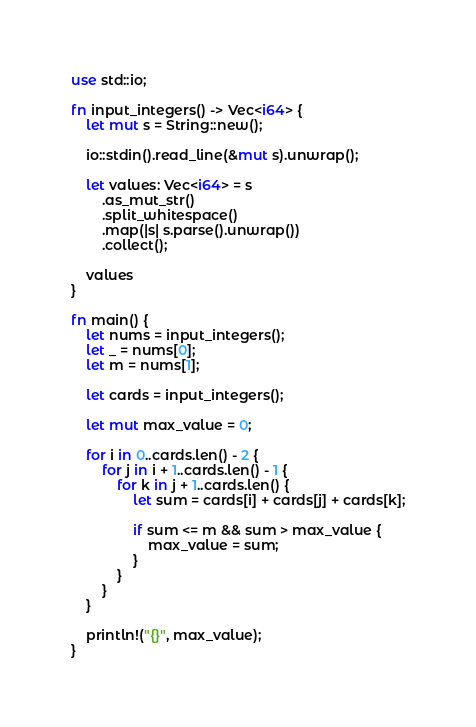<code> <loc_0><loc_0><loc_500><loc_500><_Rust_>use std::io;

fn input_integers() -> Vec<i64> {
    let mut s = String::new();

    io::stdin().read_line(&mut s).unwrap();

    let values: Vec<i64> = s
        .as_mut_str()
        .split_whitespace()
        .map(|s| s.parse().unwrap())
        .collect();

    values
}

fn main() {
    let nums = input_integers();
    let _ = nums[0];
    let m = nums[1];

    let cards = input_integers();

    let mut max_value = 0;

    for i in 0..cards.len() - 2 {
        for j in i + 1..cards.len() - 1 {
            for k in j + 1..cards.len() {
                let sum = cards[i] + cards[j] + cards[k];

                if sum <= m && sum > max_value {
                    max_value = sum;
                }
            }
        }
    }

    println!("{}", max_value);
}
</code> 